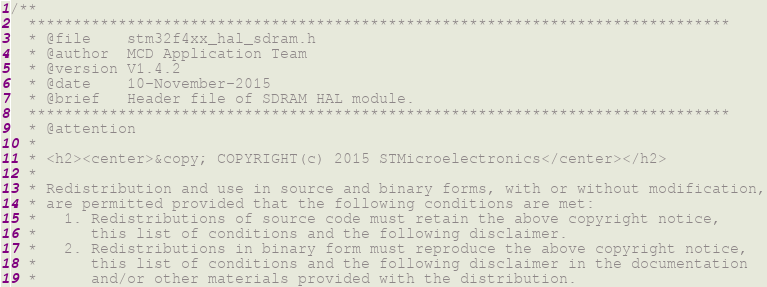Convert code to text. <code><loc_0><loc_0><loc_500><loc_500><_C_>/**
  ******************************************************************************
  * @file    stm32f4xx_hal_sdram.h
  * @author  MCD Application Team
  * @version V1.4.2
  * @date    10-November-2015
  * @brief   Header file of SDRAM HAL module.
  ******************************************************************************
  * @attention
  *
  * <h2><center>&copy; COPYRIGHT(c) 2015 STMicroelectronics</center></h2>
  *
  * Redistribution and use in source and binary forms, with or without modification,
  * are permitted provided that the following conditions are met:
  *   1. Redistributions of source code must retain the above copyright notice,
  *      this list of conditions and the following disclaimer.
  *   2. Redistributions in binary form must reproduce the above copyright notice,
  *      this list of conditions and the following disclaimer in the documentation
  *      and/or other materials provided with the distribution.</code> 